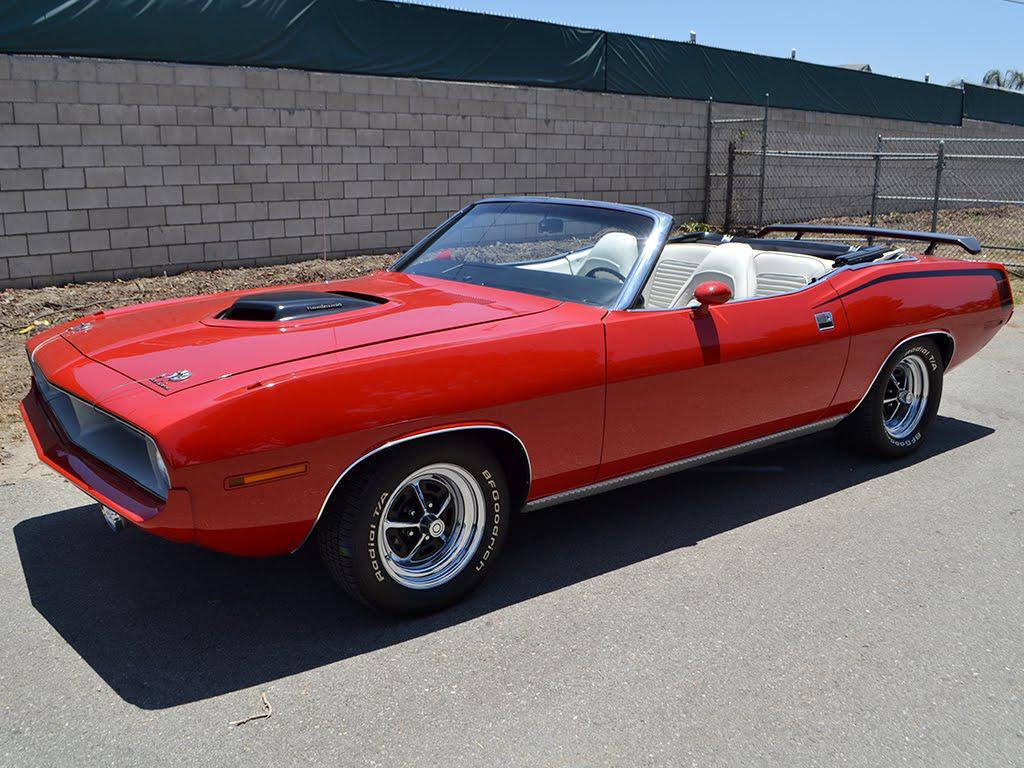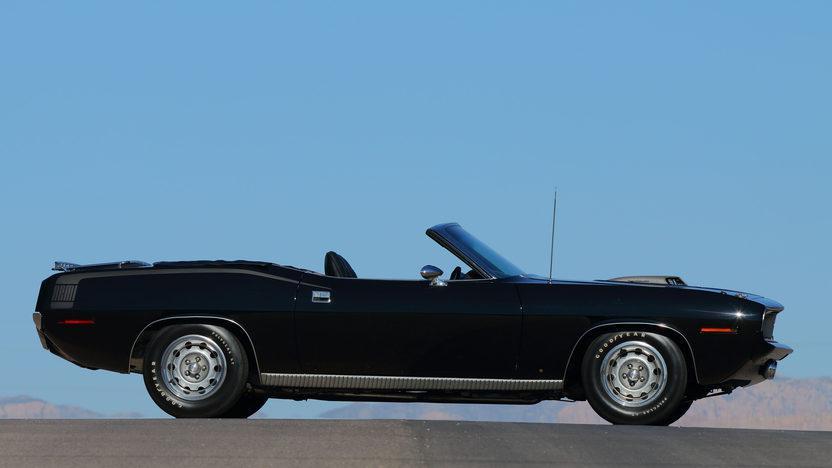The first image is the image on the left, the second image is the image on the right. Analyze the images presented: Is the assertion "At least one image shows a car with a white interior and white decal over the rear fender." valid? Answer yes or no. No. 